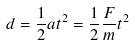<formula> <loc_0><loc_0><loc_500><loc_500>d = \frac { 1 } { 2 } a t ^ { 2 } = \frac { 1 } { 2 } \frac { F } { m } t ^ { 2 }</formula> 